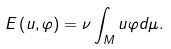Convert formula to latex. <formula><loc_0><loc_0><loc_500><loc_500>E \left ( u , \varphi \right ) = \nu \int _ { M } u \varphi d \mu .</formula> 